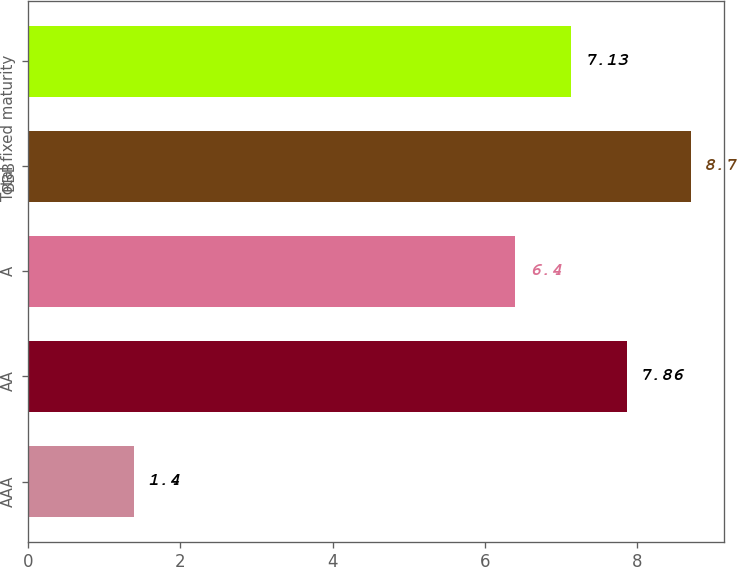Convert chart to OTSL. <chart><loc_0><loc_0><loc_500><loc_500><bar_chart><fcel>AAA<fcel>AA<fcel>A<fcel>BBB<fcel>Total fixed maturity<nl><fcel>1.4<fcel>7.86<fcel>6.4<fcel>8.7<fcel>7.13<nl></chart> 